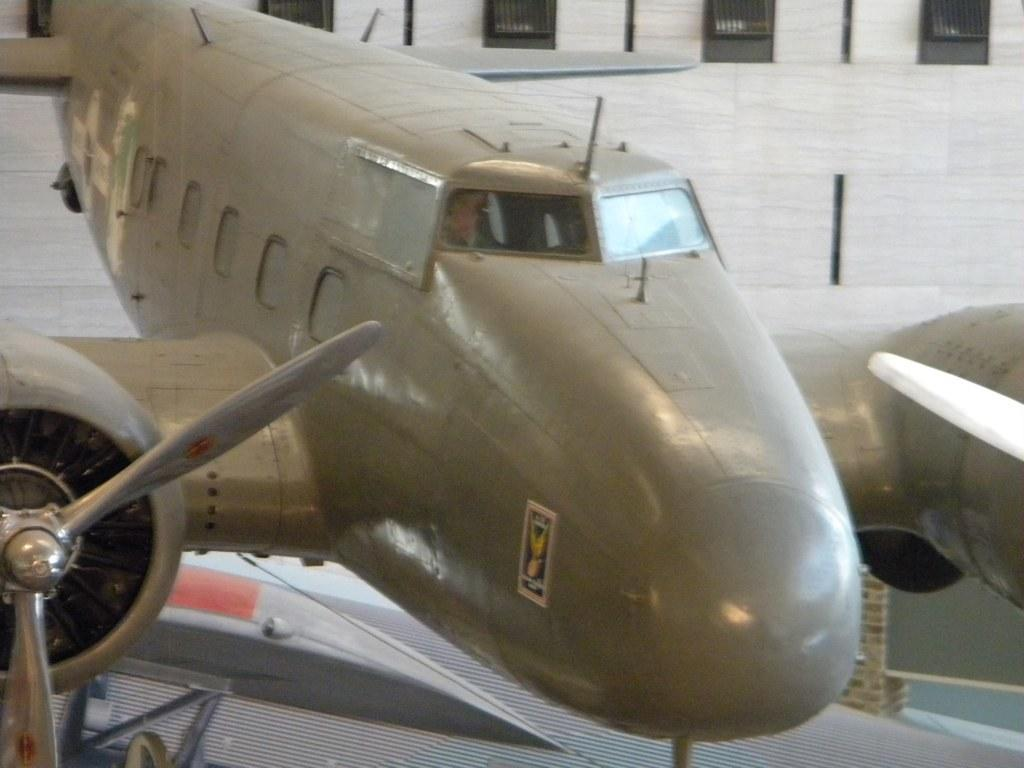What is the main subject of the image? The main subject of the image is an aeroplane. Where is the aeroplane located in the image? The aeroplane is on the floor in the image. What can be seen in the background of the image? There are grills in the background of the image. What type of beef is being grilled in the image? There is no beef or grilling activity present in the image; it only features an aeroplane on the floor and grills in the background. Is the tiger causing any trouble with the aeroplane in the image? There is no tiger present in the image, so it cannot be causing any trouble. 